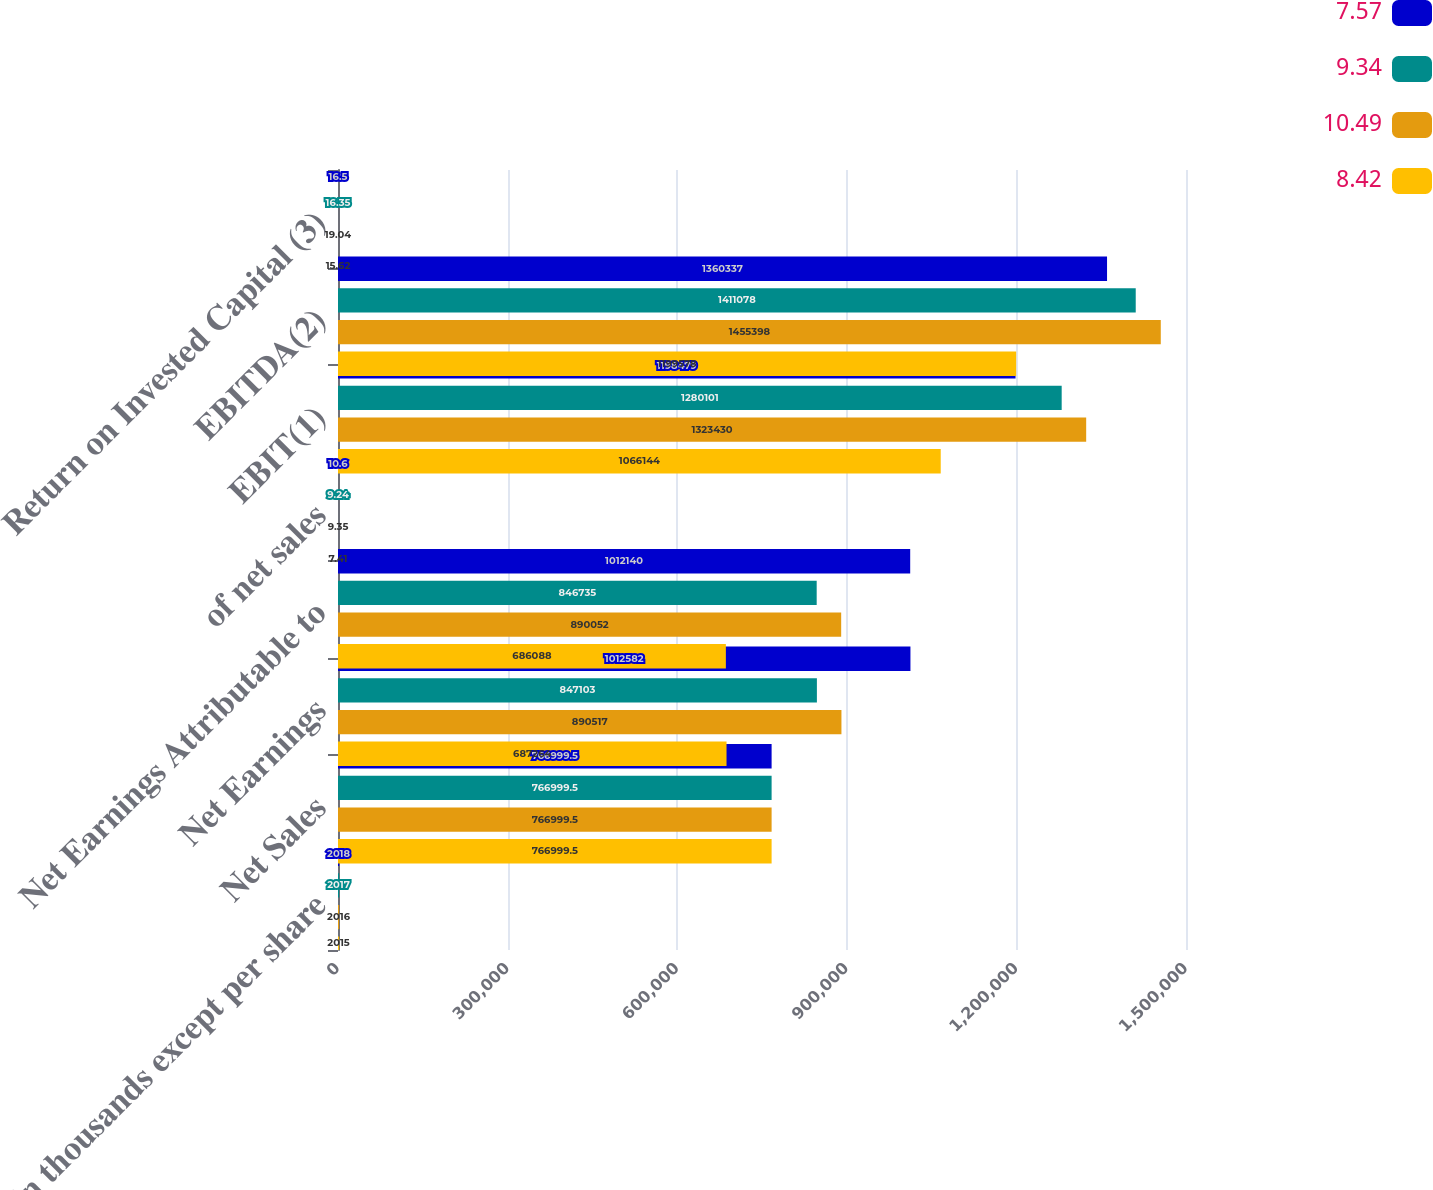Convert chart. <chart><loc_0><loc_0><loc_500><loc_500><stacked_bar_chart><ecel><fcel>(in thousands except per share<fcel>Net Sales<fcel>Net Earnings<fcel>Net Earnings Attributable to<fcel>of net sales<fcel>EBIT(1)<fcel>EBITDA(2)<fcel>Return on Invested Capital (3)<nl><fcel>7.57<fcel>2018<fcel>767000<fcel>1.01258e+06<fcel>1.01214e+06<fcel>10.6<fcel>1.19848e+06<fcel>1.36034e+06<fcel>16.5<nl><fcel>9.34<fcel>2017<fcel>767000<fcel>847103<fcel>846735<fcel>9.24<fcel>1.2801e+06<fcel>1.41108e+06<fcel>16.35<nl><fcel>10.49<fcel>2016<fcel>767000<fcel>890517<fcel>890052<fcel>9.35<fcel>1.32343e+06<fcel>1.4554e+06<fcel>19.04<nl><fcel>8.42<fcel>2015<fcel>767000<fcel>687264<fcel>686088<fcel>7.41<fcel>1.06614e+06<fcel>1.19958e+06<fcel>15.62<nl></chart> 